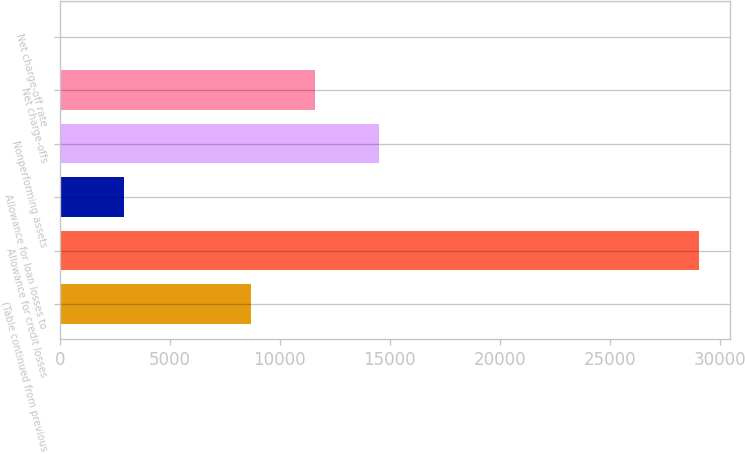<chart> <loc_0><loc_0><loc_500><loc_500><bar_chart><fcel>(Table continued from previous<fcel>Allowance for credit losses<fcel>Allowance for loan losses to<fcel>Nonperforming assets<fcel>Net charge-offs<fcel>Net charge-off rate<nl><fcel>8711.82<fcel>29036<fcel>2904.9<fcel>14518.7<fcel>11615.3<fcel>1.44<nl></chart> 